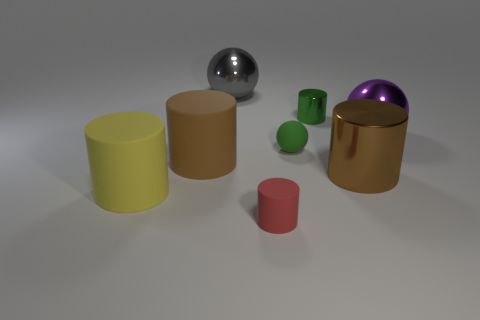What number of small shiny things are the same color as the tiny rubber sphere?
Your answer should be compact. 1. There is a brown metal thing; are there any metal cylinders on the left side of it?
Make the answer very short. Yes. Is the size of the purple ball the same as the gray metal object?
Offer a terse response. Yes. The purple shiny object that is the same shape as the gray metal object is what size?
Give a very brief answer. Large. Is there any other thing that has the same size as the yellow rubber cylinder?
Provide a succinct answer. Yes. What material is the gray thing behind the big brown object right of the tiny green sphere?
Offer a very short reply. Metal. Is the big gray object the same shape as the big yellow matte thing?
Provide a short and direct response. No. What number of big things are both left of the green ball and right of the yellow matte thing?
Offer a very short reply. 2. Are there an equal number of small objects that are in front of the small red thing and purple balls that are behind the purple shiny ball?
Your answer should be very brief. Yes. There is a matte object left of the large brown matte thing; does it have the same size as the rubber object in front of the yellow matte object?
Offer a terse response. No. 